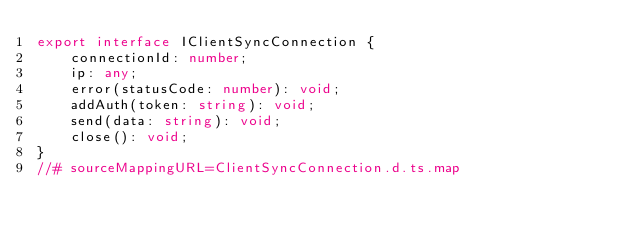<code> <loc_0><loc_0><loc_500><loc_500><_TypeScript_>export interface IClientSyncConnection {
    connectionId: number;
    ip: any;
    error(statusCode: number): void;
    addAuth(token: string): void;
    send(data: string): void;
    close(): void;
}
//# sourceMappingURL=ClientSyncConnection.d.ts.map</code> 